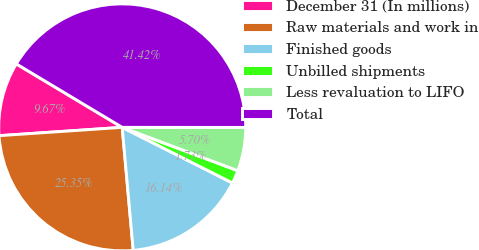Convert chart. <chart><loc_0><loc_0><loc_500><loc_500><pie_chart><fcel>December 31 (In millions)<fcel>Raw materials and work in<fcel>Finished goods<fcel>Unbilled shipments<fcel>Less revaluation to LIFO<fcel>Total<nl><fcel>9.67%<fcel>25.35%<fcel>16.14%<fcel>1.73%<fcel>5.7%<fcel>41.42%<nl></chart> 